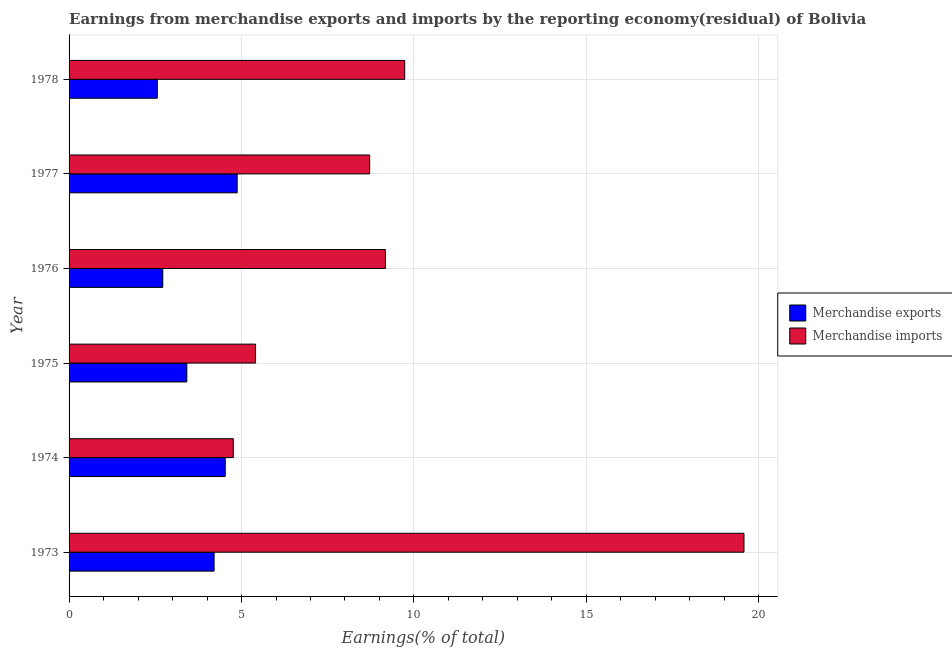How many groups of bars are there?
Offer a very short reply. 6. Are the number of bars on each tick of the Y-axis equal?
Provide a short and direct response. Yes. What is the label of the 5th group of bars from the top?
Your answer should be very brief. 1974. What is the earnings from merchandise imports in 1977?
Offer a terse response. 8.72. Across all years, what is the maximum earnings from merchandise exports?
Your answer should be very brief. 4.87. Across all years, what is the minimum earnings from merchandise imports?
Your response must be concise. 4.76. In which year was the earnings from merchandise exports maximum?
Ensure brevity in your answer.  1977. In which year was the earnings from merchandise imports minimum?
Offer a terse response. 1974. What is the total earnings from merchandise imports in the graph?
Keep it short and to the point. 57.36. What is the difference between the earnings from merchandise exports in 1973 and that in 1976?
Your response must be concise. 1.49. What is the difference between the earnings from merchandise exports in 1975 and the earnings from merchandise imports in 1976?
Offer a terse response. -5.76. What is the average earnings from merchandise exports per year?
Offer a terse response. 3.72. In the year 1975, what is the difference between the earnings from merchandise imports and earnings from merchandise exports?
Offer a very short reply. 1.99. In how many years, is the earnings from merchandise imports greater than 13 %?
Keep it short and to the point. 1. What is the ratio of the earnings from merchandise exports in 1975 to that in 1977?
Provide a succinct answer. 0.7. What is the difference between the highest and the second highest earnings from merchandise imports?
Provide a short and direct response. 9.84. What is the difference between the highest and the lowest earnings from merchandise exports?
Offer a very short reply. 2.32. What does the 1st bar from the bottom in 1975 represents?
Offer a very short reply. Merchandise exports. How many years are there in the graph?
Your answer should be compact. 6. What is the difference between two consecutive major ticks on the X-axis?
Provide a succinct answer. 5. Does the graph contain grids?
Keep it short and to the point. Yes. Where does the legend appear in the graph?
Keep it short and to the point. Center right. How are the legend labels stacked?
Your answer should be very brief. Vertical. What is the title of the graph?
Make the answer very short. Earnings from merchandise exports and imports by the reporting economy(residual) of Bolivia. What is the label or title of the X-axis?
Your response must be concise. Earnings(% of total). What is the label or title of the Y-axis?
Your response must be concise. Year. What is the Earnings(% of total) of Merchandise exports in 1973?
Ensure brevity in your answer.  4.2. What is the Earnings(% of total) of Merchandise imports in 1973?
Your answer should be very brief. 19.57. What is the Earnings(% of total) in Merchandise exports in 1974?
Offer a very short reply. 4.53. What is the Earnings(% of total) in Merchandise imports in 1974?
Keep it short and to the point. 4.76. What is the Earnings(% of total) in Merchandise exports in 1975?
Keep it short and to the point. 3.41. What is the Earnings(% of total) in Merchandise imports in 1975?
Provide a succinct answer. 5.41. What is the Earnings(% of total) of Merchandise exports in 1976?
Offer a very short reply. 2.72. What is the Earnings(% of total) of Merchandise imports in 1976?
Offer a very short reply. 9.17. What is the Earnings(% of total) of Merchandise exports in 1977?
Keep it short and to the point. 4.87. What is the Earnings(% of total) in Merchandise imports in 1977?
Provide a succinct answer. 8.72. What is the Earnings(% of total) in Merchandise exports in 1978?
Provide a succinct answer. 2.56. What is the Earnings(% of total) of Merchandise imports in 1978?
Provide a short and direct response. 9.73. Across all years, what is the maximum Earnings(% of total) of Merchandise exports?
Offer a very short reply. 4.87. Across all years, what is the maximum Earnings(% of total) of Merchandise imports?
Your answer should be compact. 19.57. Across all years, what is the minimum Earnings(% of total) of Merchandise exports?
Ensure brevity in your answer.  2.56. Across all years, what is the minimum Earnings(% of total) in Merchandise imports?
Your answer should be compact. 4.76. What is the total Earnings(% of total) in Merchandise exports in the graph?
Your answer should be very brief. 22.3. What is the total Earnings(% of total) in Merchandise imports in the graph?
Provide a short and direct response. 57.36. What is the difference between the Earnings(% of total) of Merchandise exports in 1973 and that in 1974?
Keep it short and to the point. -0.32. What is the difference between the Earnings(% of total) of Merchandise imports in 1973 and that in 1974?
Ensure brevity in your answer.  14.81. What is the difference between the Earnings(% of total) in Merchandise exports in 1973 and that in 1975?
Give a very brief answer. 0.79. What is the difference between the Earnings(% of total) in Merchandise imports in 1973 and that in 1975?
Offer a terse response. 14.16. What is the difference between the Earnings(% of total) in Merchandise exports in 1973 and that in 1976?
Make the answer very short. 1.49. What is the difference between the Earnings(% of total) of Merchandise imports in 1973 and that in 1976?
Ensure brevity in your answer.  10.4. What is the difference between the Earnings(% of total) of Merchandise exports in 1973 and that in 1977?
Provide a succinct answer. -0.67. What is the difference between the Earnings(% of total) in Merchandise imports in 1973 and that in 1977?
Keep it short and to the point. 10.85. What is the difference between the Earnings(% of total) in Merchandise exports in 1973 and that in 1978?
Keep it short and to the point. 1.65. What is the difference between the Earnings(% of total) of Merchandise imports in 1973 and that in 1978?
Give a very brief answer. 9.84. What is the difference between the Earnings(% of total) of Merchandise exports in 1974 and that in 1975?
Your response must be concise. 1.11. What is the difference between the Earnings(% of total) in Merchandise imports in 1974 and that in 1975?
Keep it short and to the point. -0.65. What is the difference between the Earnings(% of total) of Merchandise exports in 1974 and that in 1976?
Provide a short and direct response. 1.81. What is the difference between the Earnings(% of total) in Merchandise imports in 1974 and that in 1976?
Your answer should be compact. -4.41. What is the difference between the Earnings(% of total) of Merchandise exports in 1974 and that in 1977?
Provide a succinct answer. -0.35. What is the difference between the Earnings(% of total) in Merchandise imports in 1974 and that in 1977?
Give a very brief answer. -3.95. What is the difference between the Earnings(% of total) of Merchandise exports in 1974 and that in 1978?
Provide a succinct answer. 1.97. What is the difference between the Earnings(% of total) in Merchandise imports in 1974 and that in 1978?
Keep it short and to the point. -4.97. What is the difference between the Earnings(% of total) in Merchandise exports in 1975 and that in 1976?
Give a very brief answer. 0.7. What is the difference between the Earnings(% of total) in Merchandise imports in 1975 and that in 1976?
Make the answer very short. -3.77. What is the difference between the Earnings(% of total) in Merchandise exports in 1975 and that in 1977?
Keep it short and to the point. -1.46. What is the difference between the Earnings(% of total) in Merchandise imports in 1975 and that in 1977?
Offer a very short reply. -3.31. What is the difference between the Earnings(% of total) in Merchandise exports in 1975 and that in 1978?
Ensure brevity in your answer.  0.86. What is the difference between the Earnings(% of total) in Merchandise imports in 1975 and that in 1978?
Provide a short and direct response. -4.32. What is the difference between the Earnings(% of total) of Merchandise exports in 1976 and that in 1977?
Make the answer very short. -2.16. What is the difference between the Earnings(% of total) in Merchandise imports in 1976 and that in 1977?
Give a very brief answer. 0.46. What is the difference between the Earnings(% of total) in Merchandise exports in 1976 and that in 1978?
Your answer should be very brief. 0.16. What is the difference between the Earnings(% of total) of Merchandise imports in 1976 and that in 1978?
Keep it short and to the point. -0.56. What is the difference between the Earnings(% of total) of Merchandise exports in 1977 and that in 1978?
Your answer should be compact. 2.32. What is the difference between the Earnings(% of total) in Merchandise imports in 1977 and that in 1978?
Provide a short and direct response. -1.02. What is the difference between the Earnings(% of total) in Merchandise exports in 1973 and the Earnings(% of total) in Merchandise imports in 1974?
Offer a very short reply. -0.56. What is the difference between the Earnings(% of total) in Merchandise exports in 1973 and the Earnings(% of total) in Merchandise imports in 1975?
Give a very brief answer. -1.2. What is the difference between the Earnings(% of total) in Merchandise exports in 1973 and the Earnings(% of total) in Merchandise imports in 1976?
Ensure brevity in your answer.  -4.97. What is the difference between the Earnings(% of total) in Merchandise exports in 1973 and the Earnings(% of total) in Merchandise imports in 1977?
Ensure brevity in your answer.  -4.51. What is the difference between the Earnings(% of total) in Merchandise exports in 1973 and the Earnings(% of total) in Merchandise imports in 1978?
Offer a terse response. -5.53. What is the difference between the Earnings(% of total) of Merchandise exports in 1974 and the Earnings(% of total) of Merchandise imports in 1975?
Provide a short and direct response. -0.88. What is the difference between the Earnings(% of total) of Merchandise exports in 1974 and the Earnings(% of total) of Merchandise imports in 1976?
Ensure brevity in your answer.  -4.65. What is the difference between the Earnings(% of total) in Merchandise exports in 1974 and the Earnings(% of total) in Merchandise imports in 1977?
Give a very brief answer. -4.19. What is the difference between the Earnings(% of total) in Merchandise exports in 1974 and the Earnings(% of total) in Merchandise imports in 1978?
Offer a very short reply. -5.2. What is the difference between the Earnings(% of total) of Merchandise exports in 1975 and the Earnings(% of total) of Merchandise imports in 1976?
Your response must be concise. -5.76. What is the difference between the Earnings(% of total) of Merchandise exports in 1975 and the Earnings(% of total) of Merchandise imports in 1977?
Give a very brief answer. -5.3. What is the difference between the Earnings(% of total) in Merchandise exports in 1975 and the Earnings(% of total) in Merchandise imports in 1978?
Offer a very short reply. -6.32. What is the difference between the Earnings(% of total) in Merchandise exports in 1976 and the Earnings(% of total) in Merchandise imports in 1977?
Make the answer very short. -6. What is the difference between the Earnings(% of total) in Merchandise exports in 1976 and the Earnings(% of total) in Merchandise imports in 1978?
Give a very brief answer. -7.01. What is the difference between the Earnings(% of total) of Merchandise exports in 1977 and the Earnings(% of total) of Merchandise imports in 1978?
Ensure brevity in your answer.  -4.86. What is the average Earnings(% of total) in Merchandise exports per year?
Your answer should be very brief. 3.72. What is the average Earnings(% of total) of Merchandise imports per year?
Offer a very short reply. 9.56. In the year 1973, what is the difference between the Earnings(% of total) of Merchandise exports and Earnings(% of total) of Merchandise imports?
Offer a very short reply. -15.36. In the year 1974, what is the difference between the Earnings(% of total) in Merchandise exports and Earnings(% of total) in Merchandise imports?
Offer a terse response. -0.23. In the year 1975, what is the difference between the Earnings(% of total) of Merchandise exports and Earnings(% of total) of Merchandise imports?
Your answer should be very brief. -1.99. In the year 1976, what is the difference between the Earnings(% of total) of Merchandise exports and Earnings(% of total) of Merchandise imports?
Your answer should be very brief. -6.46. In the year 1977, what is the difference between the Earnings(% of total) of Merchandise exports and Earnings(% of total) of Merchandise imports?
Offer a very short reply. -3.84. In the year 1978, what is the difference between the Earnings(% of total) of Merchandise exports and Earnings(% of total) of Merchandise imports?
Give a very brief answer. -7.17. What is the ratio of the Earnings(% of total) of Merchandise exports in 1973 to that in 1974?
Give a very brief answer. 0.93. What is the ratio of the Earnings(% of total) of Merchandise imports in 1973 to that in 1974?
Ensure brevity in your answer.  4.11. What is the ratio of the Earnings(% of total) in Merchandise exports in 1973 to that in 1975?
Offer a very short reply. 1.23. What is the ratio of the Earnings(% of total) in Merchandise imports in 1973 to that in 1975?
Ensure brevity in your answer.  3.62. What is the ratio of the Earnings(% of total) in Merchandise exports in 1973 to that in 1976?
Your response must be concise. 1.55. What is the ratio of the Earnings(% of total) of Merchandise imports in 1973 to that in 1976?
Your answer should be compact. 2.13. What is the ratio of the Earnings(% of total) of Merchandise exports in 1973 to that in 1977?
Your response must be concise. 0.86. What is the ratio of the Earnings(% of total) in Merchandise imports in 1973 to that in 1977?
Make the answer very short. 2.25. What is the ratio of the Earnings(% of total) of Merchandise exports in 1973 to that in 1978?
Make the answer very short. 1.64. What is the ratio of the Earnings(% of total) in Merchandise imports in 1973 to that in 1978?
Offer a very short reply. 2.01. What is the ratio of the Earnings(% of total) in Merchandise exports in 1974 to that in 1975?
Your answer should be very brief. 1.33. What is the ratio of the Earnings(% of total) of Merchandise imports in 1974 to that in 1975?
Provide a succinct answer. 0.88. What is the ratio of the Earnings(% of total) in Merchandise exports in 1974 to that in 1976?
Your response must be concise. 1.67. What is the ratio of the Earnings(% of total) in Merchandise imports in 1974 to that in 1976?
Offer a terse response. 0.52. What is the ratio of the Earnings(% of total) in Merchandise exports in 1974 to that in 1977?
Your answer should be compact. 0.93. What is the ratio of the Earnings(% of total) of Merchandise imports in 1974 to that in 1977?
Your answer should be compact. 0.55. What is the ratio of the Earnings(% of total) in Merchandise exports in 1974 to that in 1978?
Your answer should be compact. 1.77. What is the ratio of the Earnings(% of total) in Merchandise imports in 1974 to that in 1978?
Offer a very short reply. 0.49. What is the ratio of the Earnings(% of total) in Merchandise exports in 1975 to that in 1976?
Keep it short and to the point. 1.26. What is the ratio of the Earnings(% of total) of Merchandise imports in 1975 to that in 1976?
Give a very brief answer. 0.59. What is the ratio of the Earnings(% of total) of Merchandise exports in 1975 to that in 1977?
Your response must be concise. 0.7. What is the ratio of the Earnings(% of total) in Merchandise imports in 1975 to that in 1977?
Offer a very short reply. 0.62. What is the ratio of the Earnings(% of total) in Merchandise exports in 1975 to that in 1978?
Your answer should be very brief. 1.33. What is the ratio of the Earnings(% of total) of Merchandise imports in 1975 to that in 1978?
Offer a terse response. 0.56. What is the ratio of the Earnings(% of total) in Merchandise exports in 1976 to that in 1977?
Your response must be concise. 0.56. What is the ratio of the Earnings(% of total) of Merchandise imports in 1976 to that in 1977?
Give a very brief answer. 1.05. What is the ratio of the Earnings(% of total) in Merchandise exports in 1976 to that in 1978?
Your response must be concise. 1.06. What is the ratio of the Earnings(% of total) in Merchandise imports in 1976 to that in 1978?
Provide a succinct answer. 0.94. What is the ratio of the Earnings(% of total) in Merchandise exports in 1977 to that in 1978?
Keep it short and to the point. 1.91. What is the ratio of the Earnings(% of total) of Merchandise imports in 1977 to that in 1978?
Provide a succinct answer. 0.9. What is the difference between the highest and the second highest Earnings(% of total) of Merchandise exports?
Make the answer very short. 0.35. What is the difference between the highest and the second highest Earnings(% of total) of Merchandise imports?
Make the answer very short. 9.84. What is the difference between the highest and the lowest Earnings(% of total) in Merchandise exports?
Your answer should be very brief. 2.32. What is the difference between the highest and the lowest Earnings(% of total) in Merchandise imports?
Ensure brevity in your answer.  14.81. 